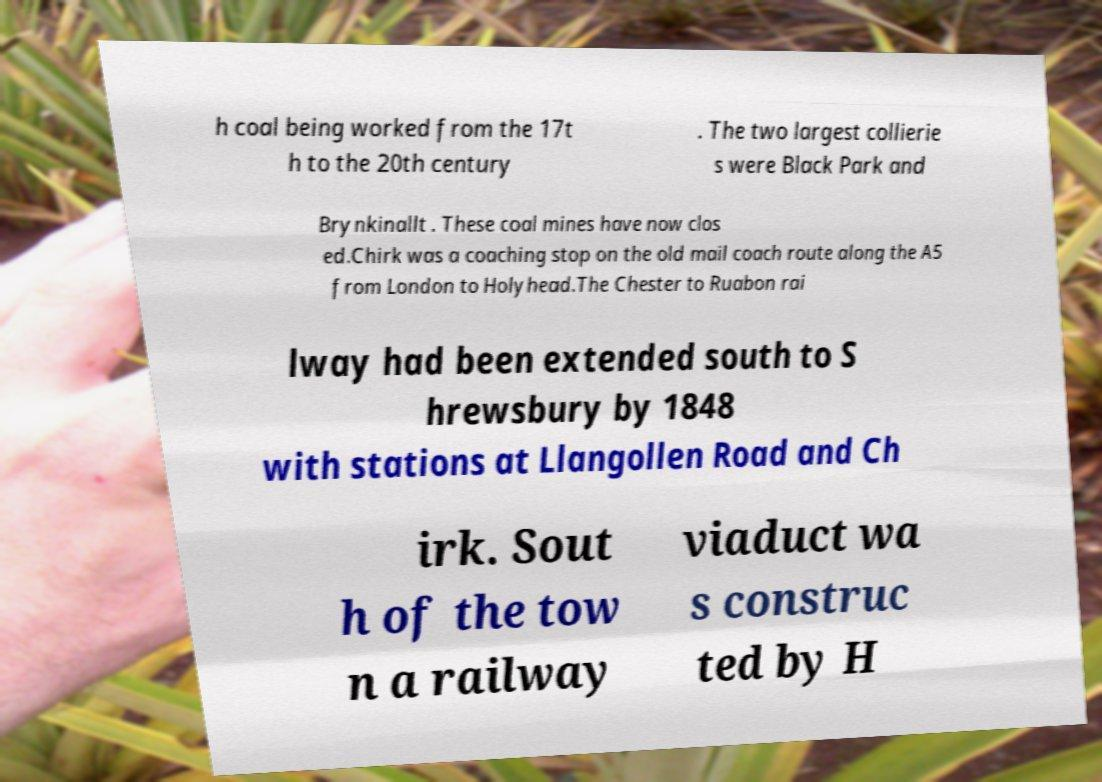Can you read and provide the text displayed in the image?This photo seems to have some interesting text. Can you extract and type it out for me? h coal being worked from the 17t h to the 20th century . The two largest collierie s were Black Park and Brynkinallt . These coal mines have now clos ed.Chirk was a coaching stop on the old mail coach route along the A5 from London to Holyhead.The Chester to Ruabon rai lway had been extended south to S hrewsbury by 1848 with stations at Llangollen Road and Ch irk. Sout h of the tow n a railway viaduct wa s construc ted by H 